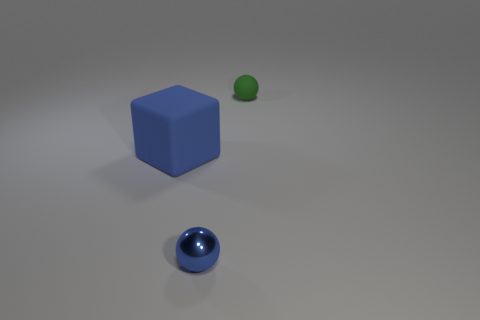Do the green object and the blue ball have the same size?
Keep it short and to the point. Yes. What number of other things are the same size as the blue shiny thing?
Offer a terse response. 1. How many objects are things in front of the small green rubber ball or tiny balls that are in front of the green sphere?
Give a very brief answer. 2. What shape is the rubber thing that is the same size as the shiny object?
Your response must be concise. Sphere. What is the size of the green sphere that is made of the same material as the big blue cube?
Keep it short and to the point. Small. Do the tiny blue metallic object and the big object have the same shape?
Ensure brevity in your answer.  No. There is a matte sphere that is the same size as the metal thing; what color is it?
Your answer should be very brief. Green. The blue metallic thing that is the same shape as the green matte thing is what size?
Ensure brevity in your answer.  Small. There is a small thing on the left side of the tiny green rubber thing; what shape is it?
Keep it short and to the point. Sphere. Does the large blue rubber object have the same shape as the tiny thing that is to the left of the tiny green ball?
Your answer should be compact. No. 